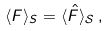Convert formula to latex. <formula><loc_0><loc_0><loc_500><loc_500>\langle F \rangle _ { S } = \langle \hat { F } \rangle _ { \mathcal { S } } \, ,</formula> 